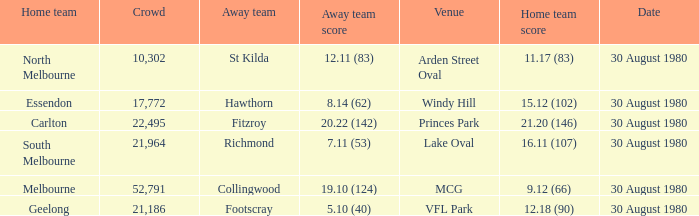What was the crowd when the away team is footscray? 21186.0. 